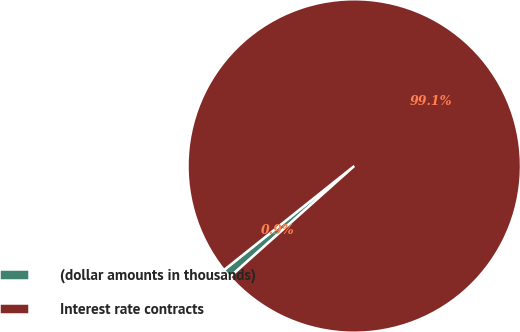Convert chart. <chart><loc_0><loc_0><loc_500><loc_500><pie_chart><fcel>(dollar amounts in thousands)<fcel>Interest rate contracts<nl><fcel>0.87%<fcel>99.13%<nl></chart> 